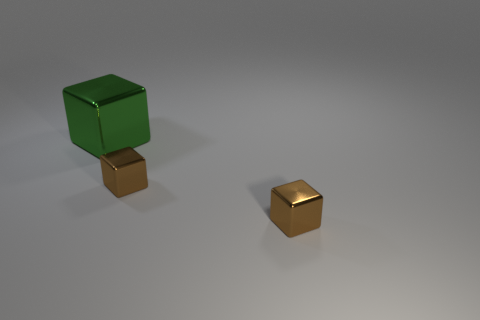There is a green block; how many green blocks are in front of it?
Your answer should be very brief. 0. How many green objects are large blocks or small objects?
Your response must be concise. 1. Are there any green rubber balls of the same size as the green metallic object?
Give a very brief answer. No. Is there another big shiny thing that has the same color as the large metallic object?
Give a very brief answer. No. What number of other things are the same shape as the big thing?
Provide a short and direct response. 2. Is there any other thing that has the same material as the large object?
Your answer should be compact. Yes. Is there anything else that is the same color as the big object?
Provide a succinct answer. No. The green metal thing has what shape?
Provide a succinct answer. Cube. Is the number of large shiny cubes greater than the number of tiny green things?
Keep it short and to the point. Yes. Is there a purple metallic sphere?
Your answer should be very brief. No. 